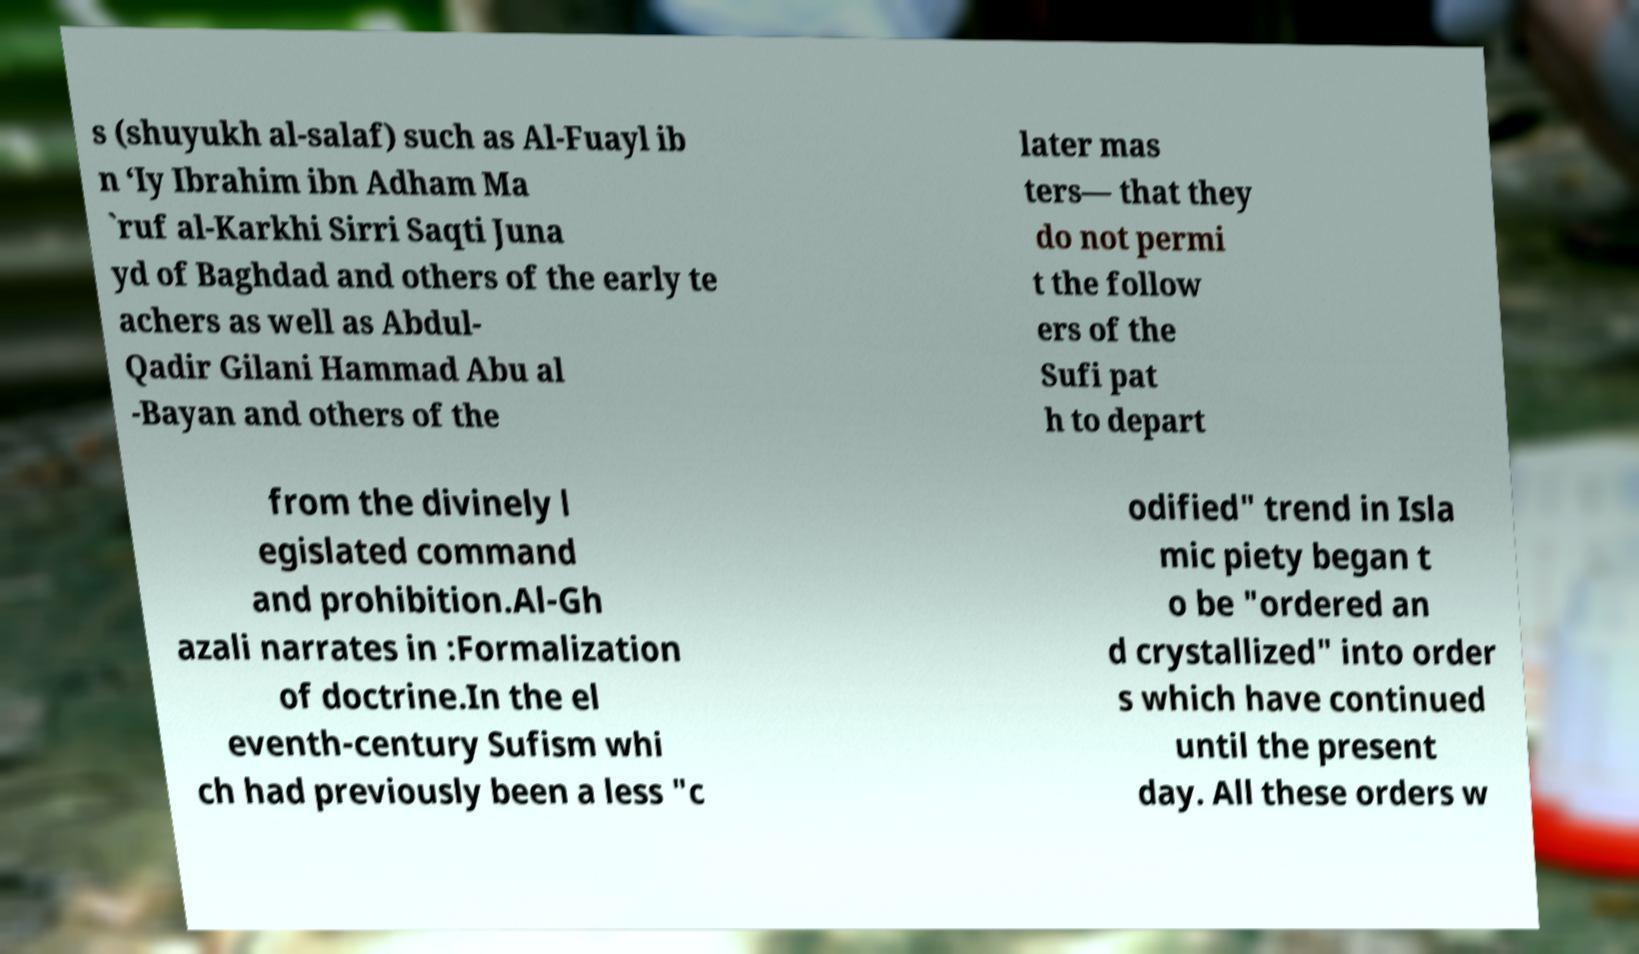What messages or text are displayed in this image? I need them in a readable, typed format. s (shuyukh al-salaf) such as Al-Fuayl ib n ‘Iy Ibrahim ibn Adham Ma `ruf al-Karkhi Sirri Saqti Juna yd of Baghdad and others of the early te achers as well as Abdul- Qadir Gilani Hammad Abu al -Bayan and others of the later mas ters— that they do not permi t the follow ers of the Sufi pat h to depart from the divinely l egislated command and prohibition.Al-Gh azali narrates in :Formalization of doctrine.In the el eventh-century Sufism whi ch had previously been a less "c odified" trend in Isla mic piety began t o be "ordered an d crystallized" into order s which have continued until the present day. All these orders w 